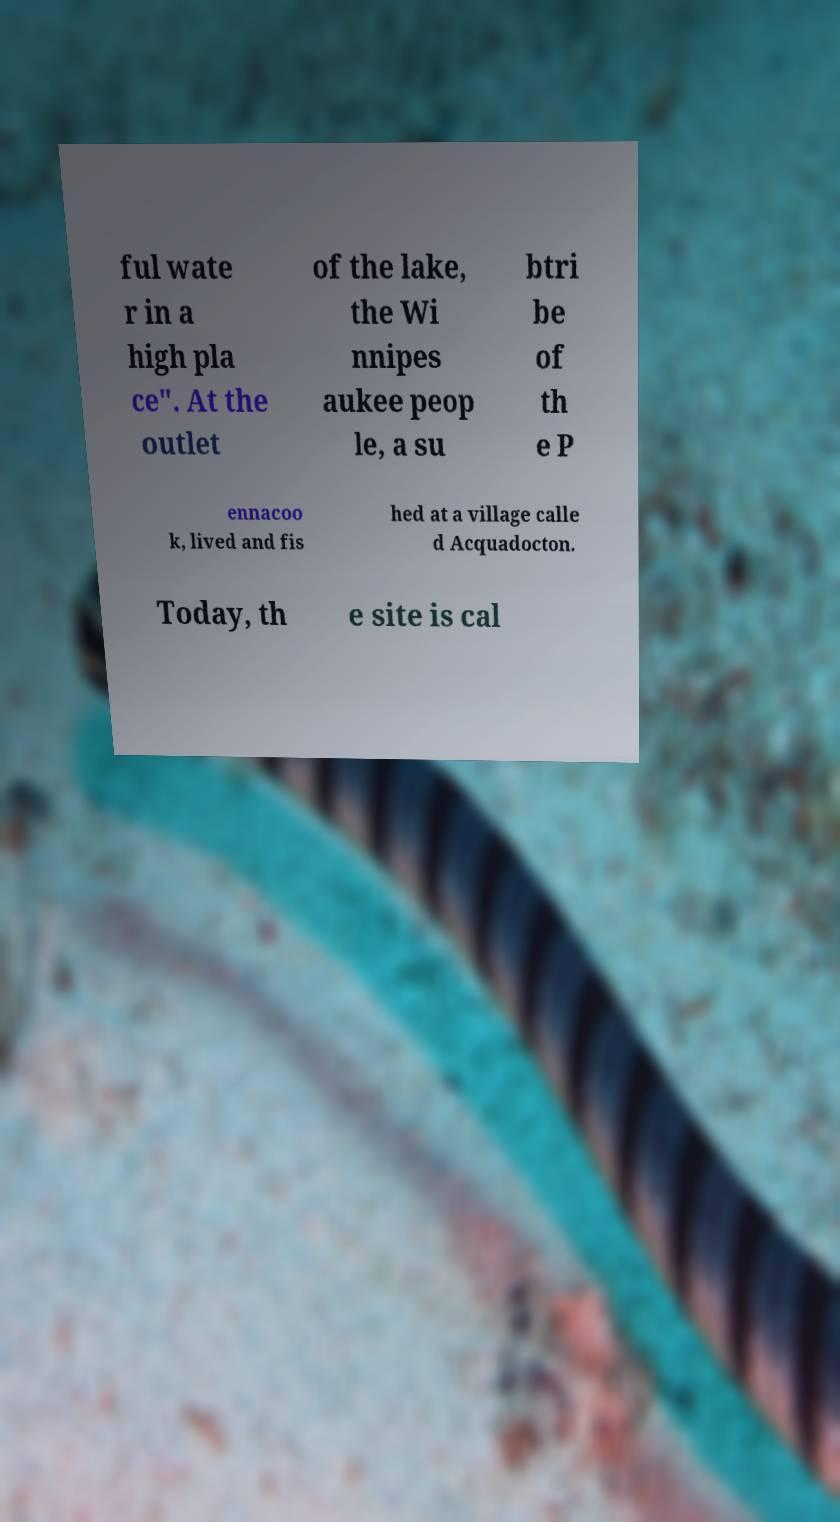For documentation purposes, I need the text within this image transcribed. Could you provide that? ful wate r in a high pla ce". At the outlet of the lake, the Wi nnipes aukee peop le, a su btri be of th e P ennacoo k, lived and fis hed at a village calle d Acquadocton. Today, th e site is cal 